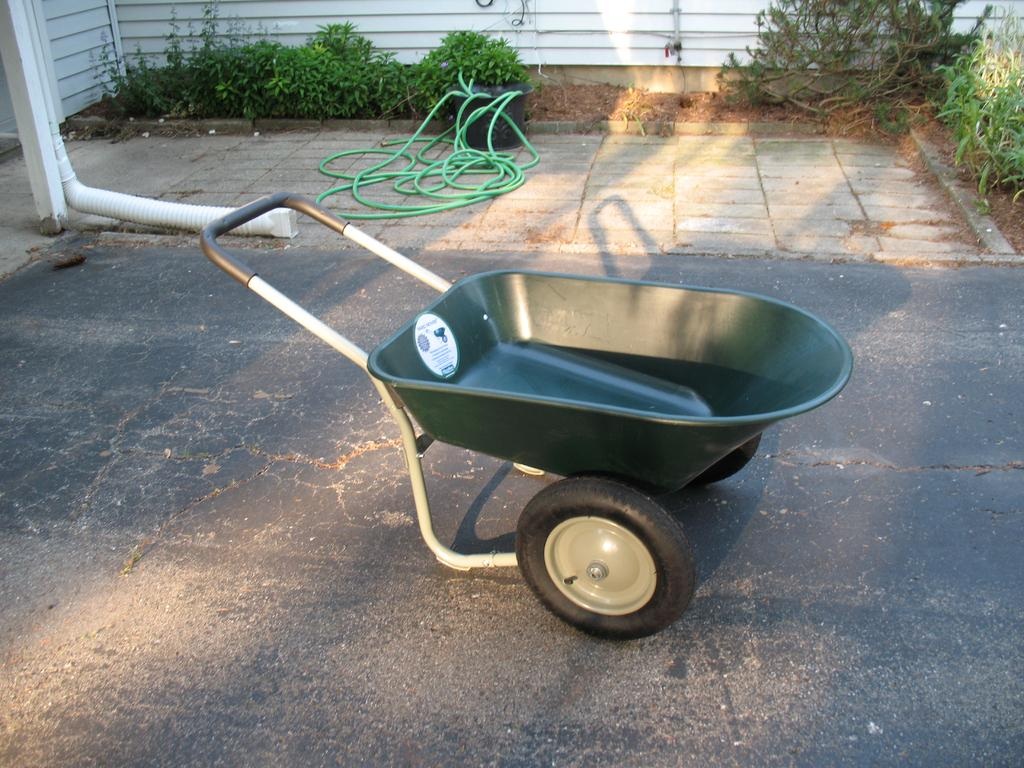What object is present in the image that is typically used for transporting items? There is a wheelbarrow in the image. What other object can be seen in the image that is related to plumbing or water supply? There is a pipe in the image. What type of vegetation is visible in the background of the image? There are plants in the background of the image. What type of structure is visible in the background of the image? There is a wall in the background of the image. How many fingers can be seen holding the wheelbarrow in the image? There are no fingers visible in the image, as it features a wheelbarrow and a pipe. What type of low-energy light bulb is present in the image? There is no light bulb present in the image. 